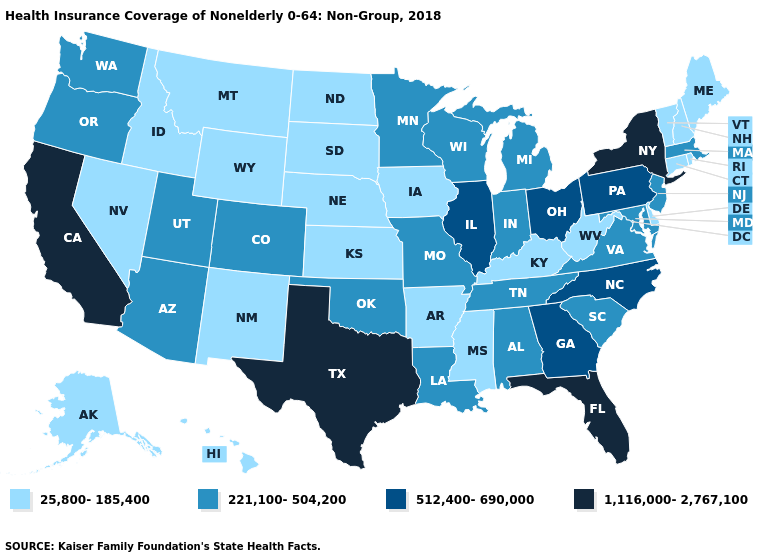Name the states that have a value in the range 1,116,000-2,767,100?
Be succinct. California, Florida, New York, Texas. What is the value of Missouri?
Short answer required. 221,100-504,200. Name the states that have a value in the range 512,400-690,000?
Keep it brief. Georgia, Illinois, North Carolina, Ohio, Pennsylvania. How many symbols are there in the legend?
Quick response, please. 4. Does Vermont have the lowest value in the Northeast?
Quick response, please. Yes. Among the states that border New Jersey , which have the lowest value?
Answer briefly. Delaware. Name the states that have a value in the range 25,800-185,400?
Short answer required. Alaska, Arkansas, Connecticut, Delaware, Hawaii, Idaho, Iowa, Kansas, Kentucky, Maine, Mississippi, Montana, Nebraska, Nevada, New Hampshire, New Mexico, North Dakota, Rhode Island, South Dakota, Vermont, West Virginia, Wyoming. What is the value of Arizona?
Write a very short answer. 221,100-504,200. What is the value of Maine?
Quick response, please. 25,800-185,400. Which states have the lowest value in the West?
Give a very brief answer. Alaska, Hawaii, Idaho, Montana, Nevada, New Mexico, Wyoming. Among the states that border Pennsylvania , which have the lowest value?
Short answer required. Delaware, West Virginia. Among the states that border Delaware , does Pennsylvania have the lowest value?
Answer briefly. No. Among the states that border Florida , which have the lowest value?
Concise answer only. Alabama. Name the states that have a value in the range 25,800-185,400?
Quick response, please. Alaska, Arkansas, Connecticut, Delaware, Hawaii, Idaho, Iowa, Kansas, Kentucky, Maine, Mississippi, Montana, Nebraska, Nevada, New Hampshire, New Mexico, North Dakota, Rhode Island, South Dakota, Vermont, West Virginia, Wyoming. Does the first symbol in the legend represent the smallest category?
Answer briefly. Yes. 